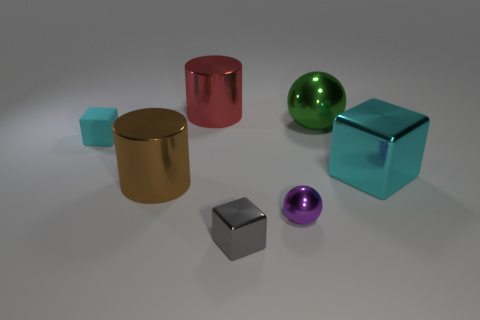What is the shape of the cyan object on the right side of the metallic ball in front of the cyan object that is left of the big red object?
Your answer should be very brief. Cube. Is the material of the small cube that is behind the gray shiny thing the same as the tiny purple sphere that is right of the rubber object?
Provide a short and direct response. No. There is a small metal thing that is in front of the tiny ball; what shape is it?
Make the answer very short. Cube. Are there fewer gray objects than purple matte spheres?
Make the answer very short. No. Are there any tiny purple metallic spheres behind the ball in front of the cyan block right of the matte cube?
Provide a succinct answer. No. How many metal things are purple objects or cyan blocks?
Your answer should be compact. 2. Does the tiny metallic ball have the same color as the large metal cube?
Make the answer very short. No. There is a brown metallic cylinder; what number of tiny cyan cubes are behind it?
Make the answer very short. 1. How many objects are both to the right of the tiny cyan cube and to the left of the big cyan object?
Keep it short and to the point. 5. What shape is the small object that is the same material as the small gray block?
Your answer should be compact. Sphere. 